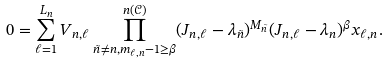Convert formula to latex. <formula><loc_0><loc_0><loc_500><loc_500>0 = \sum _ { \ell = 1 } ^ { L _ { n } } V _ { n , \ell } \prod _ { \tilde { n } \neq n , m _ { \ell , n } - 1 \geq \beta } ^ { n ( \mathcal { C } ) } ( J _ { n , \ell } - \lambda _ { \tilde { n } } ) ^ { M _ { \tilde { n } } } ( J _ { n , \ell } - \lambda _ { n } ) ^ { \beta } x _ { \ell , n } .</formula> 